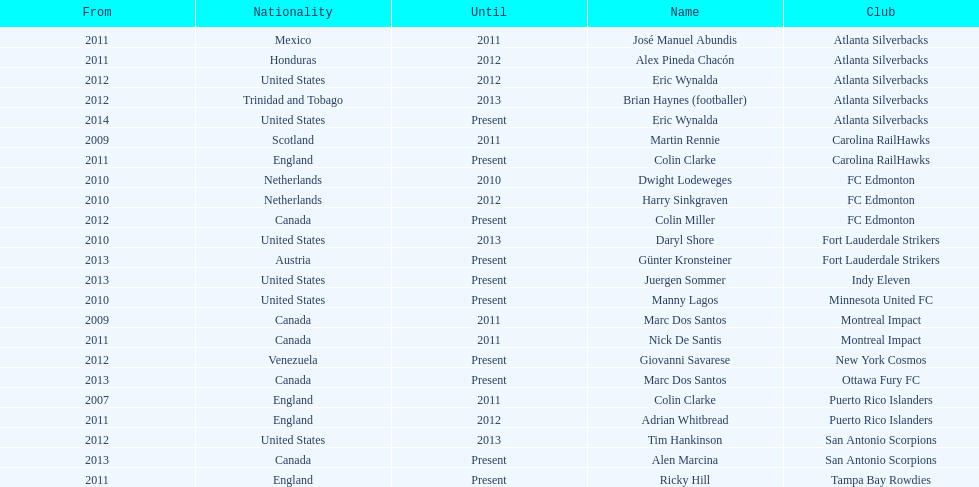Who was the coach of fc edmonton before miller? Harry Sinkgraven. 